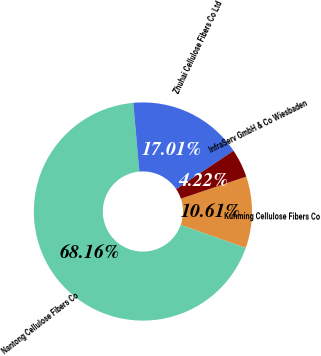Convert chart to OTSL. <chart><loc_0><loc_0><loc_500><loc_500><pie_chart><fcel>Kunming Cellulose Fibers Co<fcel>Nantong Cellulose Fibers Co<fcel>Zhuhai Cellulose Fibers Co Ltd<fcel>InfraServ GmbH & Co Wiesbaden<nl><fcel>10.61%<fcel>68.17%<fcel>17.01%<fcel>4.22%<nl></chart> 